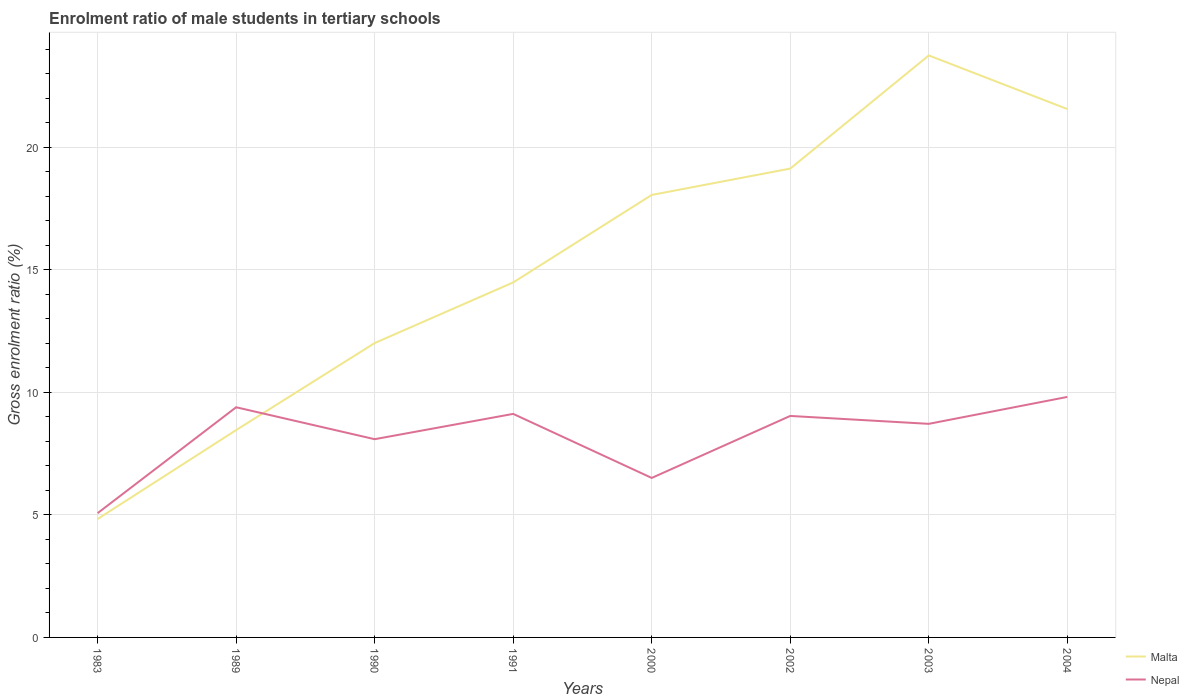Across all years, what is the maximum enrolment ratio of male students in tertiary schools in Nepal?
Offer a terse response. 5.07. What is the total enrolment ratio of male students in tertiary schools in Malta in the graph?
Your answer should be very brief. -13.1. What is the difference between the highest and the second highest enrolment ratio of male students in tertiary schools in Malta?
Offer a terse response. 18.92. What is the difference between the highest and the lowest enrolment ratio of male students in tertiary schools in Nepal?
Your answer should be very brief. 5. How many years are there in the graph?
Your answer should be very brief. 8. What is the difference between two consecutive major ticks on the Y-axis?
Give a very brief answer. 5. Are the values on the major ticks of Y-axis written in scientific E-notation?
Ensure brevity in your answer.  No. Where does the legend appear in the graph?
Your response must be concise. Bottom right. How many legend labels are there?
Provide a succinct answer. 2. What is the title of the graph?
Ensure brevity in your answer.  Enrolment ratio of male students in tertiary schools. Does "Senegal" appear as one of the legend labels in the graph?
Your answer should be very brief. No. What is the label or title of the X-axis?
Make the answer very short. Years. What is the label or title of the Y-axis?
Offer a very short reply. Gross enrolment ratio (%). What is the Gross enrolment ratio (%) of Malta in 1983?
Provide a succinct answer. 4.83. What is the Gross enrolment ratio (%) in Nepal in 1983?
Provide a succinct answer. 5.07. What is the Gross enrolment ratio (%) of Malta in 1989?
Give a very brief answer. 8.46. What is the Gross enrolment ratio (%) in Nepal in 1989?
Ensure brevity in your answer.  9.39. What is the Gross enrolment ratio (%) of Malta in 1990?
Give a very brief answer. 12.01. What is the Gross enrolment ratio (%) of Nepal in 1990?
Provide a short and direct response. 8.09. What is the Gross enrolment ratio (%) of Malta in 1991?
Offer a very short reply. 14.49. What is the Gross enrolment ratio (%) in Nepal in 1991?
Provide a succinct answer. 9.12. What is the Gross enrolment ratio (%) of Malta in 2000?
Provide a succinct answer. 18.06. What is the Gross enrolment ratio (%) of Nepal in 2000?
Keep it short and to the point. 6.51. What is the Gross enrolment ratio (%) in Malta in 2002?
Your answer should be very brief. 19.14. What is the Gross enrolment ratio (%) in Nepal in 2002?
Provide a short and direct response. 9.04. What is the Gross enrolment ratio (%) in Malta in 2003?
Give a very brief answer. 23.75. What is the Gross enrolment ratio (%) in Nepal in 2003?
Offer a very short reply. 8.72. What is the Gross enrolment ratio (%) in Malta in 2004?
Give a very brief answer. 21.56. What is the Gross enrolment ratio (%) of Nepal in 2004?
Your answer should be compact. 9.82. Across all years, what is the maximum Gross enrolment ratio (%) of Malta?
Provide a short and direct response. 23.75. Across all years, what is the maximum Gross enrolment ratio (%) in Nepal?
Your response must be concise. 9.82. Across all years, what is the minimum Gross enrolment ratio (%) in Malta?
Give a very brief answer. 4.83. Across all years, what is the minimum Gross enrolment ratio (%) in Nepal?
Offer a terse response. 5.07. What is the total Gross enrolment ratio (%) of Malta in the graph?
Offer a terse response. 122.31. What is the total Gross enrolment ratio (%) in Nepal in the graph?
Your answer should be very brief. 65.76. What is the difference between the Gross enrolment ratio (%) in Malta in 1983 and that in 1989?
Offer a terse response. -3.63. What is the difference between the Gross enrolment ratio (%) in Nepal in 1983 and that in 1989?
Ensure brevity in your answer.  -4.32. What is the difference between the Gross enrolment ratio (%) in Malta in 1983 and that in 1990?
Your answer should be compact. -7.18. What is the difference between the Gross enrolment ratio (%) in Nepal in 1983 and that in 1990?
Provide a succinct answer. -3.02. What is the difference between the Gross enrolment ratio (%) of Malta in 1983 and that in 1991?
Keep it short and to the point. -9.66. What is the difference between the Gross enrolment ratio (%) in Nepal in 1983 and that in 1991?
Your response must be concise. -4.05. What is the difference between the Gross enrolment ratio (%) in Malta in 1983 and that in 2000?
Make the answer very short. -13.23. What is the difference between the Gross enrolment ratio (%) in Nepal in 1983 and that in 2000?
Your response must be concise. -1.44. What is the difference between the Gross enrolment ratio (%) of Malta in 1983 and that in 2002?
Ensure brevity in your answer.  -14.3. What is the difference between the Gross enrolment ratio (%) in Nepal in 1983 and that in 2002?
Your answer should be very brief. -3.97. What is the difference between the Gross enrolment ratio (%) in Malta in 1983 and that in 2003?
Ensure brevity in your answer.  -18.92. What is the difference between the Gross enrolment ratio (%) of Nepal in 1983 and that in 2003?
Keep it short and to the point. -3.65. What is the difference between the Gross enrolment ratio (%) in Malta in 1983 and that in 2004?
Keep it short and to the point. -16.73. What is the difference between the Gross enrolment ratio (%) in Nepal in 1983 and that in 2004?
Keep it short and to the point. -4.74. What is the difference between the Gross enrolment ratio (%) of Malta in 1989 and that in 1990?
Give a very brief answer. -3.55. What is the difference between the Gross enrolment ratio (%) in Nepal in 1989 and that in 1990?
Give a very brief answer. 1.3. What is the difference between the Gross enrolment ratio (%) of Malta in 1989 and that in 1991?
Make the answer very short. -6.03. What is the difference between the Gross enrolment ratio (%) of Nepal in 1989 and that in 1991?
Offer a very short reply. 0.27. What is the difference between the Gross enrolment ratio (%) in Malta in 1989 and that in 2000?
Give a very brief answer. -9.6. What is the difference between the Gross enrolment ratio (%) of Nepal in 1989 and that in 2000?
Your answer should be very brief. 2.88. What is the difference between the Gross enrolment ratio (%) of Malta in 1989 and that in 2002?
Make the answer very short. -10.67. What is the difference between the Gross enrolment ratio (%) of Nepal in 1989 and that in 2002?
Make the answer very short. 0.35. What is the difference between the Gross enrolment ratio (%) in Malta in 1989 and that in 2003?
Offer a terse response. -15.29. What is the difference between the Gross enrolment ratio (%) of Nepal in 1989 and that in 2003?
Provide a short and direct response. 0.68. What is the difference between the Gross enrolment ratio (%) of Malta in 1989 and that in 2004?
Offer a terse response. -13.1. What is the difference between the Gross enrolment ratio (%) in Nepal in 1989 and that in 2004?
Ensure brevity in your answer.  -0.42. What is the difference between the Gross enrolment ratio (%) in Malta in 1990 and that in 1991?
Your answer should be compact. -2.48. What is the difference between the Gross enrolment ratio (%) in Nepal in 1990 and that in 1991?
Your answer should be compact. -1.03. What is the difference between the Gross enrolment ratio (%) in Malta in 1990 and that in 2000?
Make the answer very short. -6.05. What is the difference between the Gross enrolment ratio (%) in Nepal in 1990 and that in 2000?
Offer a very short reply. 1.58. What is the difference between the Gross enrolment ratio (%) of Malta in 1990 and that in 2002?
Keep it short and to the point. -7.12. What is the difference between the Gross enrolment ratio (%) in Nepal in 1990 and that in 2002?
Offer a terse response. -0.95. What is the difference between the Gross enrolment ratio (%) in Malta in 1990 and that in 2003?
Make the answer very short. -11.74. What is the difference between the Gross enrolment ratio (%) in Nepal in 1990 and that in 2003?
Your answer should be compact. -0.63. What is the difference between the Gross enrolment ratio (%) in Malta in 1990 and that in 2004?
Provide a short and direct response. -9.55. What is the difference between the Gross enrolment ratio (%) of Nepal in 1990 and that in 2004?
Offer a very short reply. -1.72. What is the difference between the Gross enrolment ratio (%) in Malta in 1991 and that in 2000?
Make the answer very short. -3.57. What is the difference between the Gross enrolment ratio (%) of Nepal in 1991 and that in 2000?
Your answer should be compact. 2.61. What is the difference between the Gross enrolment ratio (%) of Malta in 1991 and that in 2002?
Ensure brevity in your answer.  -4.65. What is the difference between the Gross enrolment ratio (%) in Nepal in 1991 and that in 2002?
Make the answer very short. 0.08. What is the difference between the Gross enrolment ratio (%) of Malta in 1991 and that in 2003?
Your answer should be very brief. -9.26. What is the difference between the Gross enrolment ratio (%) in Nepal in 1991 and that in 2003?
Provide a short and direct response. 0.41. What is the difference between the Gross enrolment ratio (%) in Malta in 1991 and that in 2004?
Your response must be concise. -7.08. What is the difference between the Gross enrolment ratio (%) of Nepal in 1991 and that in 2004?
Keep it short and to the point. -0.69. What is the difference between the Gross enrolment ratio (%) in Malta in 2000 and that in 2002?
Your answer should be compact. -1.08. What is the difference between the Gross enrolment ratio (%) of Nepal in 2000 and that in 2002?
Offer a terse response. -2.53. What is the difference between the Gross enrolment ratio (%) of Malta in 2000 and that in 2003?
Provide a short and direct response. -5.69. What is the difference between the Gross enrolment ratio (%) in Nepal in 2000 and that in 2003?
Ensure brevity in your answer.  -2.21. What is the difference between the Gross enrolment ratio (%) of Malta in 2000 and that in 2004?
Offer a very short reply. -3.5. What is the difference between the Gross enrolment ratio (%) of Nepal in 2000 and that in 2004?
Offer a terse response. -3.31. What is the difference between the Gross enrolment ratio (%) in Malta in 2002 and that in 2003?
Make the answer very short. -4.62. What is the difference between the Gross enrolment ratio (%) in Nepal in 2002 and that in 2003?
Provide a short and direct response. 0.32. What is the difference between the Gross enrolment ratio (%) in Malta in 2002 and that in 2004?
Keep it short and to the point. -2.43. What is the difference between the Gross enrolment ratio (%) in Nepal in 2002 and that in 2004?
Give a very brief answer. -0.78. What is the difference between the Gross enrolment ratio (%) of Malta in 2003 and that in 2004?
Provide a short and direct response. 2.19. What is the difference between the Gross enrolment ratio (%) of Nepal in 2003 and that in 2004?
Provide a succinct answer. -1.1. What is the difference between the Gross enrolment ratio (%) in Malta in 1983 and the Gross enrolment ratio (%) in Nepal in 1989?
Offer a very short reply. -4.56. What is the difference between the Gross enrolment ratio (%) in Malta in 1983 and the Gross enrolment ratio (%) in Nepal in 1990?
Your answer should be compact. -3.26. What is the difference between the Gross enrolment ratio (%) of Malta in 1983 and the Gross enrolment ratio (%) of Nepal in 1991?
Your answer should be compact. -4.29. What is the difference between the Gross enrolment ratio (%) in Malta in 1983 and the Gross enrolment ratio (%) in Nepal in 2000?
Make the answer very short. -1.68. What is the difference between the Gross enrolment ratio (%) in Malta in 1983 and the Gross enrolment ratio (%) in Nepal in 2002?
Your answer should be very brief. -4.21. What is the difference between the Gross enrolment ratio (%) in Malta in 1983 and the Gross enrolment ratio (%) in Nepal in 2003?
Offer a terse response. -3.88. What is the difference between the Gross enrolment ratio (%) of Malta in 1983 and the Gross enrolment ratio (%) of Nepal in 2004?
Your answer should be very brief. -4.98. What is the difference between the Gross enrolment ratio (%) of Malta in 1989 and the Gross enrolment ratio (%) of Nepal in 1990?
Offer a terse response. 0.37. What is the difference between the Gross enrolment ratio (%) of Malta in 1989 and the Gross enrolment ratio (%) of Nepal in 1991?
Make the answer very short. -0.66. What is the difference between the Gross enrolment ratio (%) of Malta in 1989 and the Gross enrolment ratio (%) of Nepal in 2000?
Your answer should be very brief. 1.95. What is the difference between the Gross enrolment ratio (%) of Malta in 1989 and the Gross enrolment ratio (%) of Nepal in 2002?
Your answer should be compact. -0.58. What is the difference between the Gross enrolment ratio (%) in Malta in 1989 and the Gross enrolment ratio (%) in Nepal in 2003?
Give a very brief answer. -0.26. What is the difference between the Gross enrolment ratio (%) of Malta in 1989 and the Gross enrolment ratio (%) of Nepal in 2004?
Your response must be concise. -1.35. What is the difference between the Gross enrolment ratio (%) of Malta in 1990 and the Gross enrolment ratio (%) of Nepal in 1991?
Provide a succinct answer. 2.89. What is the difference between the Gross enrolment ratio (%) in Malta in 1990 and the Gross enrolment ratio (%) in Nepal in 2000?
Offer a very short reply. 5.5. What is the difference between the Gross enrolment ratio (%) in Malta in 1990 and the Gross enrolment ratio (%) in Nepal in 2002?
Keep it short and to the point. 2.97. What is the difference between the Gross enrolment ratio (%) of Malta in 1990 and the Gross enrolment ratio (%) of Nepal in 2003?
Give a very brief answer. 3.3. What is the difference between the Gross enrolment ratio (%) of Malta in 1990 and the Gross enrolment ratio (%) of Nepal in 2004?
Give a very brief answer. 2.2. What is the difference between the Gross enrolment ratio (%) of Malta in 1991 and the Gross enrolment ratio (%) of Nepal in 2000?
Make the answer very short. 7.98. What is the difference between the Gross enrolment ratio (%) in Malta in 1991 and the Gross enrolment ratio (%) in Nepal in 2002?
Make the answer very short. 5.45. What is the difference between the Gross enrolment ratio (%) of Malta in 1991 and the Gross enrolment ratio (%) of Nepal in 2003?
Make the answer very short. 5.77. What is the difference between the Gross enrolment ratio (%) in Malta in 1991 and the Gross enrolment ratio (%) in Nepal in 2004?
Provide a short and direct response. 4.67. What is the difference between the Gross enrolment ratio (%) of Malta in 2000 and the Gross enrolment ratio (%) of Nepal in 2002?
Offer a terse response. 9.02. What is the difference between the Gross enrolment ratio (%) in Malta in 2000 and the Gross enrolment ratio (%) in Nepal in 2003?
Your answer should be very brief. 9.34. What is the difference between the Gross enrolment ratio (%) of Malta in 2000 and the Gross enrolment ratio (%) of Nepal in 2004?
Your answer should be compact. 8.24. What is the difference between the Gross enrolment ratio (%) in Malta in 2002 and the Gross enrolment ratio (%) in Nepal in 2003?
Provide a succinct answer. 10.42. What is the difference between the Gross enrolment ratio (%) of Malta in 2002 and the Gross enrolment ratio (%) of Nepal in 2004?
Ensure brevity in your answer.  9.32. What is the difference between the Gross enrolment ratio (%) of Malta in 2003 and the Gross enrolment ratio (%) of Nepal in 2004?
Your answer should be very brief. 13.94. What is the average Gross enrolment ratio (%) in Malta per year?
Offer a terse response. 15.29. What is the average Gross enrolment ratio (%) in Nepal per year?
Make the answer very short. 8.22. In the year 1983, what is the difference between the Gross enrolment ratio (%) of Malta and Gross enrolment ratio (%) of Nepal?
Give a very brief answer. -0.24. In the year 1989, what is the difference between the Gross enrolment ratio (%) in Malta and Gross enrolment ratio (%) in Nepal?
Provide a succinct answer. -0.93. In the year 1990, what is the difference between the Gross enrolment ratio (%) in Malta and Gross enrolment ratio (%) in Nepal?
Make the answer very short. 3.92. In the year 1991, what is the difference between the Gross enrolment ratio (%) of Malta and Gross enrolment ratio (%) of Nepal?
Provide a short and direct response. 5.37. In the year 2000, what is the difference between the Gross enrolment ratio (%) in Malta and Gross enrolment ratio (%) in Nepal?
Your response must be concise. 11.55. In the year 2002, what is the difference between the Gross enrolment ratio (%) of Malta and Gross enrolment ratio (%) of Nepal?
Your answer should be very brief. 10.1. In the year 2003, what is the difference between the Gross enrolment ratio (%) of Malta and Gross enrolment ratio (%) of Nepal?
Your response must be concise. 15.04. In the year 2004, what is the difference between the Gross enrolment ratio (%) of Malta and Gross enrolment ratio (%) of Nepal?
Offer a very short reply. 11.75. What is the ratio of the Gross enrolment ratio (%) of Malta in 1983 to that in 1989?
Ensure brevity in your answer.  0.57. What is the ratio of the Gross enrolment ratio (%) of Nepal in 1983 to that in 1989?
Your answer should be very brief. 0.54. What is the ratio of the Gross enrolment ratio (%) of Malta in 1983 to that in 1990?
Your answer should be compact. 0.4. What is the ratio of the Gross enrolment ratio (%) in Nepal in 1983 to that in 1990?
Offer a terse response. 0.63. What is the ratio of the Gross enrolment ratio (%) of Malta in 1983 to that in 1991?
Your answer should be compact. 0.33. What is the ratio of the Gross enrolment ratio (%) in Nepal in 1983 to that in 1991?
Make the answer very short. 0.56. What is the ratio of the Gross enrolment ratio (%) in Malta in 1983 to that in 2000?
Provide a succinct answer. 0.27. What is the ratio of the Gross enrolment ratio (%) of Nepal in 1983 to that in 2000?
Your answer should be very brief. 0.78. What is the ratio of the Gross enrolment ratio (%) of Malta in 1983 to that in 2002?
Your response must be concise. 0.25. What is the ratio of the Gross enrolment ratio (%) in Nepal in 1983 to that in 2002?
Your answer should be very brief. 0.56. What is the ratio of the Gross enrolment ratio (%) of Malta in 1983 to that in 2003?
Give a very brief answer. 0.2. What is the ratio of the Gross enrolment ratio (%) of Nepal in 1983 to that in 2003?
Your answer should be very brief. 0.58. What is the ratio of the Gross enrolment ratio (%) of Malta in 1983 to that in 2004?
Your answer should be compact. 0.22. What is the ratio of the Gross enrolment ratio (%) of Nepal in 1983 to that in 2004?
Your answer should be very brief. 0.52. What is the ratio of the Gross enrolment ratio (%) of Malta in 1989 to that in 1990?
Offer a terse response. 0.7. What is the ratio of the Gross enrolment ratio (%) in Nepal in 1989 to that in 1990?
Make the answer very short. 1.16. What is the ratio of the Gross enrolment ratio (%) of Malta in 1989 to that in 1991?
Ensure brevity in your answer.  0.58. What is the ratio of the Gross enrolment ratio (%) in Nepal in 1989 to that in 1991?
Your answer should be very brief. 1.03. What is the ratio of the Gross enrolment ratio (%) in Malta in 1989 to that in 2000?
Offer a terse response. 0.47. What is the ratio of the Gross enrolment ratio (%) in Nepal in 1989 to that in 2000?
Your answer should be compact. 1.44. What is the ratio of the Gross enrolment ratio (%) in Malta in 1989 to that in 2002?
Make the answer very short. 0.44. What is the ratio of the Gross enrolment ratio (%) in Nepal in 1989 to that in 2002?
Make the answer very short. 1.04. What is the ratio of the Gross enrolment ratio (%) in Malta in 1989 to that in 2003?
Your response must be concise. 0.36. What is the ratio of the Gross enrolment ratio (%) in Nepal in 1989 to that in 2003?
Your response must be concise. 1.08. What is the ratio of the Gross enrolment ratio (%) in Malta in 1989 to that in 2004?
Your response must be concise. 0.39. What is the ratio of the Gross enrolment ratio (%) in Nepal in 1989 to that in 2004?
Keep it short and to the point. 0.96. What is the ratio of the Gross enrolment ratio (%) of Malta in 1990 to that in 1991?
Ensure brevity in your answer.  0.83. What is the ratio of the Gross enrolment ratio (%) of Nepal in 1990 to that in 1991?
Keep it short and to the point. 0.89. What is the ratio of the Gross enrolment ratio (%) of Malta in 1990 to that in 2000?
Offer a terse response. 0.67. What is the ratio of the Gross enrolment ratio (%) of Nepal in 1990 to that in 2000?
Provide a succinct answer. 1.24. What is the ratio of the Gross enrolment ratio (%) in Malta in 1990 to that in 2002?
Your response must be concise. 0.63. What is the ratio of the Gross enrolment ratio (%) in Nepal in 1990 to that in 2002?
Offer a very short reply. 0.9. What is the ratio of the Gross enrolment ratio (%) of Malta in 1990 to that in 2003?
Make the answer very short. 0.51. What is the ratio of the Gross enrolment ratio (%) in Nepal in 1990 to that in 2003?
Your answer should be very brief. 0.93. What is the ratio of the Gross enrolment ratio (%) in Malta in 1990 to that in 2004?
Make the answer very short. 0.56. What is the ratio of the Gross enrolment ratio (%) in Nepal in 1990 to that in 2004?
Give a very brief answer. 0.82. What is the ratio of the Gross enrolment ratio (%) of Malta in 1991 to that in 2000?
Your response must be concise. 0.8. What is the ratio of the Gross enrolment ratio (%) in Nepal in 1991 to that in 2000?
Provide a short and direct response. 1.4. What is the ratio of the Gross enrolment ratio (%) in Malta in 1991 to that in 2002?
Your answer should be very brief. 0.76. What is the ratio of the Gross enrolment ratio (%) in Nepal in 1991 to that in 2002?
Give a very brief answer. 1.01. What is the ratio of the Gross enrolment ratio (%) in Malta in 1991 to that in 2003?
Make the answer very short. 0.61. What is the ratio of the Gross enrolment ratio (%) in Nepal in 1991 to that in 2003?
Provide a short and direct response. 1.05. What is the ratio of the Gross enrolment ratio (%) in Malta in 1991 to that in 2004?
Provide a succinct answer. 0.67. What is the ratio of the Gross enrolment ratio (%) in Nepal in 1991 to that in 2004?
Make the answer very short. 0.93. What is the ratio of the Gross enrolment ratio (%) of Malta in 2000 to that in 2002?
Offer a very short reply. 0.94. What is the ratio of the Gross enrolment ratio (%) in Nepal in 2000 to that in 2002?
Offer a very short reply. 0.72. What is the ratio of the Gross enrolment ratio (%) of Malta in 2000 to that in 2003?
Keep it short and to the point. 0.76. What is the ratio of the Gross enrolment ratio (%) of Nepal in 2000 to that in 2003?
Make the answer very short. 0.75. What is the ratio of the Gross enrolment ratio (%) in Malta in 2000 to that in 2004?
Give a very brief answer. 0.84. What is the ratio of the Gross enrolment ratio (%) of Nepal in 2000 to that in 2004?
Provide a succinct answer. 0.66. What is the ratio of the Gross enrolment ratio (%) of Malta in 2002 to that in 2003?
Give a very brief answer. 0.81. What is the ratio of the Gross enrolment ratio (%) in Malta in 2002 to that in 2004?
Your response must be concise. 0.89. What is the ratio of the Gross enrolment ratio (%) of Nepal in 2002 to that in 2004?
Provide a short and direct response. 0.92. What is the ratio of the Gross enrolment ratio (%) in Malta in 2003 to that in 2004?
Give a very brief answer. 1.1. What is the ratio of the Gross enrolment ratio (%) in Nepal in 2003 to that in 2004?
Keep it short and to the point. 0.89. What is the difference between the highest and the second highest Gross enrolment ratio (%) of Malta?
Make the answer very short. 2.19. What is the difference between the highest and the second highest Gross enrolment ratio (%) in Nepal?
Your response must be concise. 0.42. What is the difference between the highest and the lowest Gross enrolment ratio (%) of Malta?
Provide a short and direct response. 18.92. What is the difference between the highest and the lowest Gross enrolment ratio (%) of Nepal?
Your response must be concise. 4.74. 